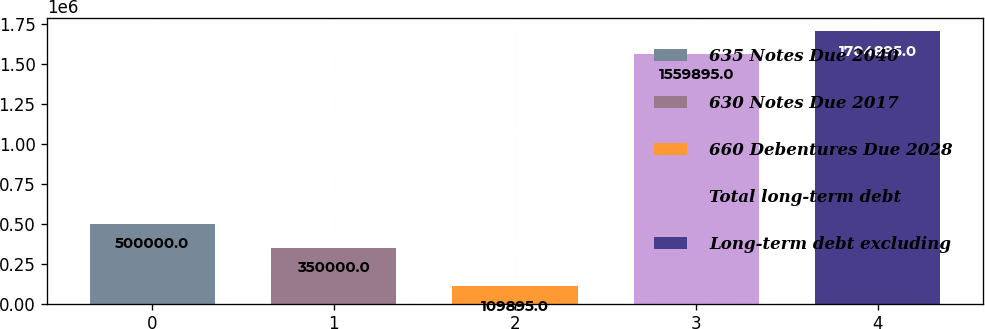<chart> <loc_0><loc_0><loc_500><loc_500><bar_chart><fcel>635 Notes Due 2040<fcel>630 Notes Due 2017<fcel>660 Debentures Due 2028<fcel>Total long-term debt<fcel>Long-term debt excluding<nl><fcel>500000<fcel>350000<fcel>109895<fcel>1.5599e+06<fcel>1.7049e+06<nl></chart> 